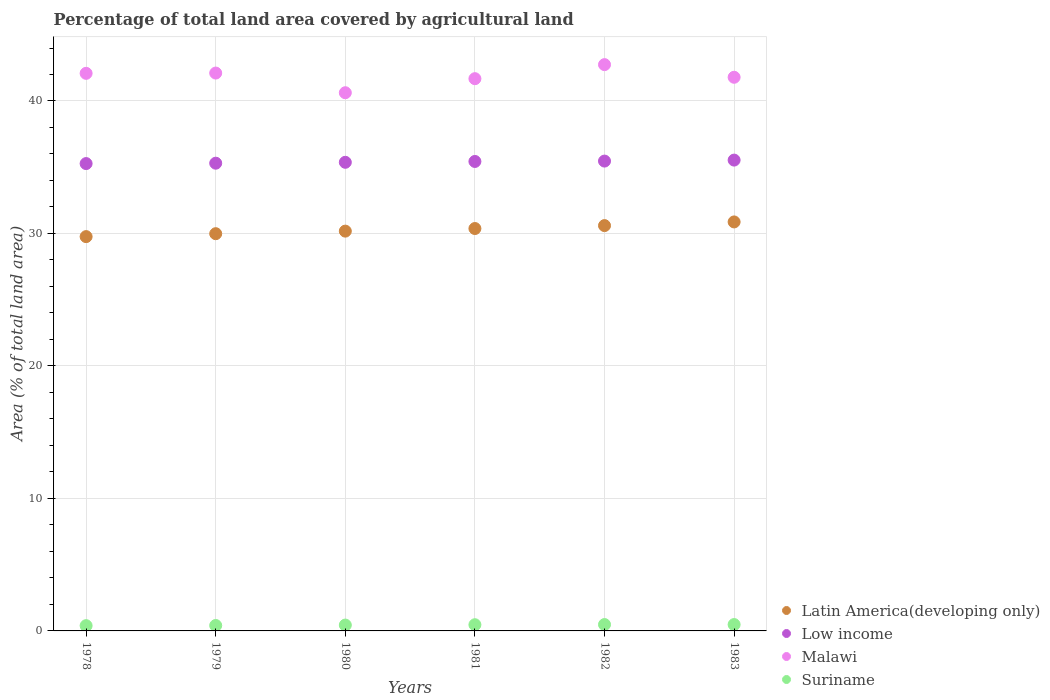Is the number of dotlines equal to the number of legend labels?
Make the answer very short. Yes. What is the percentage of agricultural land in Low income in 1982?
Offer a terse response. 35.46. Across all years, what is the maximum percentage of agricultural land in Low income?
Your response must be concise. 35.54. Across all years, what is the minimum percentage of agricultural land in Malawi?
Keep it short and to the point. 40.62. In which year was the percentage of agricultural land in Malawi maximum?
Keep it short and to the point. 1982. In which year was the percentage of agricultural land in Malawi minimum?
Your response must be concise. 1980. What is the total percentage of agricultural land in Latin America(developing only) in the graph?
Your response must be concise. 181.76. What is the difference between the percentage of agricultural land in Latin America(developing only) in 1980 and that in 1982?
Keep it short and to the point. -0.42. What is the difference between the percentage of agricultural land in Malawi in 1979 and the percentage of agricultural land in Latin America(developing only) in 1983?
Your answer should be compact. 11.24. What is the average percentage of agricultural land in Latin America(developing only) per year?
Provide a succinct answer. 30.29. In the year 1979, what is the difference between the percentage of agricultural land in Latin America(developing only) and percentage of agricultural land in Suriname?
Your answer should be very brief. 29.57. In how many years, is the percentage of agricultural land in Latin America(developing only) greater than 36 %?
Provide a succinct answer. 0. What is the ratio of the percentage of agricultural land in Malawi in 1978 to that in 1982?
Give a very brief answer. 0.98. What is the difference between the highest and the second highest percentage of agricultural land in Latin America(developing only)?
Ensure brevity in your answer.  0.28. What is the difference between the highest and the lowest percentage of agricultural land in Suriname?
Your answer should be very brief. 0.08. In how many years, is the percentage of agricultural land in Latin America(developing only) greater than the average percentage of agricultural land in Latin America(developing only) taken over all years?
Keep it short and to the point. 3. Does the percentage of agricultural land in Malawi monotonically increase over the years?
Provide a succinct answer. No. Is the percentage of agricultural land in Low income strictly less than the percentage of agricultural land in Malawi over the years?
Your response must be concise. Yes. What is the difference between two consecutive major ticks on the Y-axis?
Give a very brief answer. 10. Are the values on the major ticks of Y-axis written in scientific E-notation?
Make the answer very short. No. Does the graph contain any zero values?
Keep it short and to the point. No. Where does the legend appear in the graph?
Ensure brevity in your answer.  Bottom right. How many legend labels are there?
Make the answer very short. 4. How are the legend labels stacked?
Your answer should be compact. Vertical. What is the title of the graph?
Your answer should be compact. Percentage of total land area covered by agricultural land. Does "Peru" appear as one of the legend labels in the graph?
Make the answer very short. No. What is the label or title of the X-axis?
Provide a succinct answer. Years. What is the label or title of the Y-axis?
Provide a succinct answer. Area (% of total land area). What is the Area (% of total land area) of Latin America(developing only) in 1978?
Offer a very short reply. 29.76. What is the Area (% of total land area) in Low income in 1978?
Provide a short and direct response. 35.28. What is the Area (% of total land area) in Malawi in 1978?
Make the answer very short. 42.09. What is the Area (% of total land area) in Suriname in 1978?
Your answer should be very brief. 0.4. What is the Area (% of total land area) in Latin America(developing only) in 1979?
Your answer should be compact. 29.98. What is the Area (% of total land area) of Low income in 1979?
Your response must be concise. 35.31. What is the Area (% of total land area) of Malawi in 1979?
Ensure brevity in your answer.  42.11. What is the Area (% of total land area) in Suriname in 1979?
Your answer should be compact. 0.41. What is the Area (% of total land area) in Latin America(developing only) in 1980?
Make the answer very short. 30.18. What is the Area (% of total land area) in Low income in 1980?
Your answer should be very brief. 35.37. What is the Area (% of total land area) in Malawi in 1980?
Make the answer very short. 40.62. What is the Area (% of total land area) in Suriname in 1980?
Offer a very short reply. 0.44. What is the Area (% of total land area) in Latin America(developing only) in 1981?
Your response must be concise. 30.37. What is the Area (% of total land area) in Low income in 1981?
Keep it short and to the point. 35.44. What is the Area (% of total land area) in Malawi in 1981?
Provide a succinct answer. 41.68. What is the Area (% of total land area) of Suriname in 1981?
Your response must be concise. 0.47. What is the Area (% of total land area) of Latin America(developing only) in 1982?
Give a very brief answer. 30.59. What is the Area (% of total land area) in Low income in 1982?
Give a very brief answer. 35.46. What is the Area (% of total land area) of Malawi in 1982?
Your response must be concise. 42.75. What is the Area (% of total land area) in Suriname in 1982?
Make the answer very short. 0.48. What is the Area (% of total land area) of Latin America(developing only) in 1983?
Your answer should be compact. 30.87. What is the Area (% of total land area) of Low income in 1983?
Ensure brevity in your answer.  35.54. What is the Area (% of total land area) in Malawi in 1983?
Offer a very short reply. 41.79. What is the Area (% of total land area) of Suriname in 1983?
Offer a terse response. 0.48. Across all years, what is the maximum Area (% of total land area) in Latin America(developing only)?
Make the answer very short. 30.87. Across all years, what is the maximum Area (% of total land area) in Low income?
Provide a succinct answer. 35.54. Across all years, what is the maximum Area (% of total land area) in Malawi?
Your answer should be compact. 42.75. Across all years, what is the maximum Area (% of total land area) in Suriname?
Offer a terse response. 0.48. Across all years, what is the minimum Area (% of total land area) of Latin America(developing only)?
Your response must be concise. 29.76. Across all years, what is the minimum Area (% of total land area) of Low income?
Your response must be concise. 35.28. Across all years, what is the minimum Area (% of total land area) in Malawi?
Your answer should be very brief. 40.62. Across all years, what is the minimum Area (% of total land area) in Suriname?
Give a very brief answer. 0.4. What is the total Area (% of total land area) in Latin America(developing only) in the graph?
Your response must be concise. 181.76. What is the total Area (% of total land area) of Low income in the graph?
Your answer should be compact. 212.39. What is the total Area (% of total land area) in Malawi in the graph?
Provide a short and direct response. 251.04. What is the total Area (% of total land area) of Suriname in the graph?
Ensure brevity in your answer.  2.68. What is the difference between the Area (% of total land area) in Latin America(developing only) in 1978 and that in 1979?
Your answer should be very brief. -0.22. What is the difference between the Area (% of total land area) in Low income in 1978 and that in 1979?
Keep it short and to the point. -0.03. What is the difference between the Area (% of total land area) of Malawi in 1978 and that in 1979?
Offer a terse response. -0.02. What is the difference between the Area (% of total land area) of Suriname in 1978 and that in 1979?
Your response must be concise. -0.01. What is the difference between the Area (% of total land area) of Latin America(developing only) in 1978 and that in 1980?
Provide a succinct answer. -0.41. What is the difference between the Area (% of total land area) of Low income in 1978 and that in 1980?
Give a very brief answer. -0.1. What is the difference between the Area (% of total land area) of Malawi in 1978 and that in 1980?
Offer a terse response. 1.46. What is the difference between the Area (% of total land area) in Suriname in 1978 and that in 1980?
Your response must be concise. -0.04. What is the difference between the Area (% of total land area) of Latin America(developing only) in 1978 and that in 1981?
Your answer should be very brief. -0.61. What is the difference between the Area (% of total land area) in Low income in 1978 and that in 1981?
Provide a succinct answer. -0.16. What is the difference between the Area (% of total land area) of Malawi in 1978 and that in 1981?
Make the answer very short. 0.4. What is the difference between the Area (% of total land area) of Suriname in 1978 and that in 1981?
Keep it short and to the point. -0.07. What is the difference between the Area (% of total land area) in Latin America(developing only) in 1978 and that in 1982?
Keep it short and to the point. -0.83. What is the difference between the Area (% of total land area) in Low income in 1978 and that in 1982?
Provide a short and direct response. -0.19. What is the difference between the Area (% of total land area) in Malawi in 1978 and that in 1982?
Give a very brief answer. -0.66. What is the difference between the Area (% of total land area) in Suriname in 1978 and that in 1982?
Ensure brevity in your answer.  -0.08. What is the difference between the Area (% of total land area) in Latin America(developing only) in 1978 and that in 1983?
Ensure brevity in your answer.  -1.11. What is the difference between the Area (% of total land area) of Low income in 1978 and that in 1983?
Offer a terse response. -0.26. What is the difference between the Area (% of total land area) of Malawi in 1978 and that in 1983?
Give a very brief answer. 0.3. What is the difference between the Area (% of total land area) of Suriname in 1978 and that in 1983?
Offer a very short reply. -0.08. What is the difference between the Area (% of total land area) of Latin America(developing only) in 1979 and that in 1980?
Keep it short and to the point. -0.19. What is the difference between the Area (% of total land area) of Low income in 1979 and that in 1980?
Offer a very short reply. -0.07. What is the difference between the Area (% of total land area) of Malawi in 1979 and that in 1980?
Your answer should be compact. 1.48. What is the difference between the Area (% of total land area) in Suriname in 1979 and that in 1980?
Give a very brief answer. -0.03. What is the difference between the Area (% of total land area) in Latin America(developing only) in 1979 and that in 1981?
Your response must be concise. -0.39. What is the difference between the Area (% of total land area) of Low income in 1979 and that in 1981?
Offer a terse response. -0.13. What is the difference between the Area (% of total land area) in Malawi in 1979 and that in 1981?
Offer a very short reply. 0.42. What is the difference between the Area (% of total land area) of Suriname in 1979 and that in 1981?
Offer a terse response. -0.06. What is the difference between the Area (% of total land area) of Latin America(developing only) in 1979 and that in 1982?
Your answer should be compact. -0.61. What is the difference between the Area (% of total land area) in Low income in 1979 and that in 1982?
Ensure brevity in your answer.  -0.16. What is the difference between the Area (% of total land area) in Malawi in 1979 and that in 1982?
Ensure brevity in your answer.  -0.64. What is the difference between the Area (% of total land area) in Suriname in 1979 and that in 1982?
Provide a short and direct response. -0.07. What is the difference between the Area (% of total land area) of Latin America(developing only) in 1979 and that in 1983?
Offer a terse response. -0.89. What is the difference between the Area (% of total land area) of Low income in 1979 and that in 1983?
Make the answer very short. -0.23. What is the difference between the Area (% of total land area) in Malawi in 1979 and that in 1983?
Ensure brevity in your answer.  0.32. What is the difference between the Area (% of total land area) in Suriname in 1979 and that in 1983?
Provide a succinct answer. -0.07. What is the difference between the Area (% of total land area) in Latin America(developing only) in 1980 and that in 1981?
Keep it short and to the point. -0.2. What is the difference between the Area (% of total land area) of Low income in 1980 and that in 1981?
Offer a very short reply. -0.06. What is the difference between the Area (% of total land area) in Malawi in 1980 and that in 1981?
Ensure brevity in your answer.  -1.06. What is the difference between the Area (% of total land area) of Suriname in 1980 and that in 1981?
Your response must be concise. -0.03. What is the difference between the Area (% of total land area) of Latin America(developing only) in 1980 and that in 1982?
Give a very brief answer. -0.42. What is the difference between the Area (% of total land area) of Low income in 1980 and that in 1982?
Your answer should be very brief. -0.09. What is the difference between the Area (% of total land area) in Malawi in 1980 and that in 1982?
Provide a short and direct response. -2.12. What is the difference between the Area (% of total land area) of Suriname in 1980 and that in 1982?
Give a very brief answer. -0.04. What is the difference between the Area (% of total land area) of Latin America(developing only) in 1980 and that in 1983?
Offer a very short reply. -0.69. What is the difference between the Area (% of total land area) of Low income in 1980 and that in 1983?
Offer a terse response. -0.17. What is the difference between the Area (% of total land area) in Malawi in 1980 and that in 1983?
Keep it short and to the point. -1.17. What is the difference between the Area (% of total land area) in Suriname in 1980 and that in 1983?
Your answer should be compact. -0.04. What is the difference between the Area (% of total land area) of Latin America(developing only) in 1981 and that in 1982?
Your response must be concise. -0.22. What is the difference between the Area (% of total land area) of Low income in 1981 and that in 1982?
Your answer should be very brief. -0.03. What is the difference between the Area (% of total land area) in Malawi in 1981 and that in 1982?
Ensure brevity in your answer.  -1.06. What is the difference between the Area (% of total land area) of Suriname in 1981 and that in 1982?
Your answer should be very brief. -0.01. What is the difference between the Area (% of total land area) of Latin America(developing only) in 1981 and that in 1983?
Ensure brevity in your answer.  -0.5. What is the difference between the Area (% of total land area) in Low income in 1981 and that in 1983?
Make the answer very short. -0.1. What is the difference between the Area (% of total land area) of Malawi in 1981 and that in 1983?
Your response must be concise. -0.11. What is the difference between the Area (% of total land area) in Suriname in 1981 and that in 1983?
Keep it short and to the point. -0.01. What is the difference between the Area (% of total land area) in Latin America(developing only) in 1982 and that in 1983?
Provide a short and direct response. -0.28. What is the difference between the Area (% of total land area) of Low income in 1982 and that in 1983?
Ensure brevity in your answer.  -0.07. What is the difference between the Area (% of total land area) of Malawi in 1982 and that in 1983?
Provide a short and direct response. 0.95. What is the difference between the Area (% of total land area) of Latin America(developing only) in 1978 and the Area (% of total land area) of Low income in 1979?
Your response must be concise. -5.54. What is the difference between the Area (% of total land area) in Latin America(developing only) in 1978 and the Area (% of total land area) in Malawi in 1979?
Give a very brief answer. -12.35. What is the difference between the Area (% of total land area) of Latin America(developing only) in 1978 and the Area (% of total land area) of Suriname in 1979?
Give a very brief answer. 29.35. What is the difference between the Area (% of total land area) in Low income in 1978 and the Area (% of total land area) in Malawi in 1979?
Offer a terse response. -6.83. What is the difference between the Area (% of total land area) in Low income in 1978 and the Area (% of total land area) in Suriname in 1979?
Give a very brief answer. 34.87. What is the difference between the Area (% of total land area) in Malawi in 1978 and the Area (% of total land area) in Suriname in 1979?
Make the answer very short. 41.68. What is the difference between the Area (% of total land area) in Latin America(developing only) in 1978 and the Area (% of total land area) in Low income in 1980?
Your answer should be compact. -5.61. What is the difference between the Area (% of total land area) in Latin America(developing only) in 1978 and the Area (% of total land area) in Malawi in 1980?
Keep it short and to the point. -10.86. What is the difference between the Area (% of total land area) of Latin America(developing only) in 1978 and the Area (% of total land area) of Suriname in 1980?
Offer a terse response. 29.32. What is the difference between the Area (% of total land area) in Low income in 1978 and the Area (% of total land area) in Malawi in 1980?
Provide a short and direct response. -5.35. What is the difference between the Area (% of total land area) of Low income in 1978 and the Area (% of total land area) of Suriname in 1980?
Your response must be concise. 34.83. What is the difference between the Area (% of total land area) of Malawi in 1978 and the Area (% of total land area) of Suriname in 1980?
Provide a succinct answer. 41.65. What is the difference between the Area (% of total land area) in Latin America(developing only) in 1978 and the Area (% of total land area) in Low income in 1981?
Your answer should be compact. -5.67. What is the difference between the Area (% of total land area) of Latin America(developing only) in 1978 and the Area (% of total land area) of Malawi in 1981?
Offer a terse response. -11.92. What is the difference between the Area (% of total land area) in Latin America(developing only) in 1978 and the Area (% of total land area) in Suriname in 1981?
Provide a succinct answer. 29.29. What is the difference between the Area (% of total land area) of Low income in 1978 and the Area (% of total land area) of Malawi in 1981?
Make the answer very short. -6.41. What is the difference between the Area (% of total land area) in Low income in 1978 and the Area (% of total land area) in Suriname in 1981?
Your answer should be very brief. 34.81. What is the difference between the Area (% of total land area) in Malawi in 1978 and the Area (% of total land area) in Suriname in 1981?
Ensure brevity in your answer.  41.62. What is the difference between the Area (% of total land area) of Latin America(developing only) in 1978 and the Area (% of total land area) of Low income in 1982?
Provide a short and direct response. -5.7. What is the difference between the Area (% of total land area) in Latin America(developing only) in 1978 and the Area (% of total land area) in Malawi in 1982?
Your response must be concise. -12.98. What is the difference between the Area (% of total land area) of Latin America(developing only) in 1978 and the Area (% of total land area) of Suriname in 1982?
Provide a short and direct response. 29.28. What is the difference between the Area (% of total land area) of Low income in 1978 and the Area (% of total land area) of Malawi in 1982?
Make the answer very short. -7.47. What is the difference between the Area (% of total land area) in Low income in 1978 and the Area (% of total land area) in Suriname in 1982?
Ensure brevity in your answer.  34.8. What is the difference between the Area (% of total land area) of Malawi in 1978 and the Area (% of total land area) of Suriname in 1982?
Ensure brevity in your answer.  41.61. What is the difference between the Area (% of total land area) of Latin America(developing only) in 1978 and the Area (% of total land area) of Low income in 1983?
Make the answer very short. -5.78. What is the difference between the Area (% of total land area) of Latin America(developing only) in 1978 and the Area (% of total land area) of Malawi in 1983?
Provide a succinct answer. -12.03. What is the difference between the Area (% of total land area) of Latin America(developing only) in 1978 and the Area (% of total land area) of Suriname in 1983?
Your answer should be very brief. 29.28. What is the difference between the Area (% of total land area) of Low income in 1978 and the Area (% of total land area) of Malawi in 1983?
Your answer should be compact. -6.51. What is the difference between the Area (% of total land area) in Low income in 1978 and the Area (% of total land area) in Suriname in 1983?
Give a very brief answer. 34.8. What is the difference between the Area (% of total land area) of Malawi in 1978 and the Area (% of total land area) of Suriname in 1983?
Offer a terse response. 41.61. What is the difference between the Area (% of total land area) of Latin America(developing only) in 1979 and the Area (% of total land area) of Low income in 1980?
Provide a short and direct response. -5.39. What is the difference between the Area (% of total land area) of Latin America(developing only) in 1979 and the Area (% of total land area) of Malawi in 1980?
Ensure brevity in your answer.  -10.64. What is the difference between the Area (% of total land area) of Latin America(developing only) in 1979 and the Area (% of total land area) of Suriname in 1980?
Offer a terse response. 29.54. What is the difference between the Area (% of total land area) of Low income in 1979 and the Area (% of total land area) of Malawi in 1980?
Offer a very short reply. -5.32. What is the difference between the Area (% of total land area) in Low income in 1979 and the Area (% of total land area) in Suriname in 1980?
Provide a succinct answer. 34.86. What is the difference between the Area (% of total land area) of Malawi in 1979 and the Area (% of total land area) of Suriname in 1980?
Keep it short and to the point. 41.67. What is the difference between the Area (% of total land area) in Latin America(developing only) in 1979 and the Area (% of total land area) in Low income in 1981?
Ensure brevity in your answer.  -5.45. What is the difference between the Area (% of total land area) of Latin America(developing only) in 1979 and the Area (% of total land area) of Malawi in 1981?
Your response must be concise. -11.7. What is the difference between the Area (% of total land area) of Latin America(developing only) in 1979 and the Area (% of total land area) of Suriname in 1981?
Your answer should be very brief. 29.52. What is the difference between the Area (% of total land area) of Low income in 1979 and the Area (% of total land area) of Malawi in 1981?
Offer a terse response. -6.38. What is the difference between the Area (% of total land area) of Low income in 1979 and the Area (% of total land area) of Suriname in 1981?
Provide a succinct answer. 34.84. What is the difference between the Area (% of total land area) in Malawi in 1979 and the Area (% of total land area) in Suriname in 1981?
Provide a succinct answer. 41.64. What is the difference between the Area (% of total land area) of Latin America(developing only) in 1979 and the Area (% of total land area) of Low income in 1982?
Make the answer very short. -5.48. What is the difference between the Area (% of total land area) of Latin America(developing only) in 1979 and the Area (% of total land area) of Malawi in 1982?
Ensure brevity in your answer.  -12.76. What is the difference between the Area (% of total land area) in Latin America(developing only) in 1979 and the Area (% of total land area) in Suriname in 1982?
Provide a short and direct response. 29.5. What is the difference between the Area (% of total land area) of Low income in 1979 and the Area (% of total land area) of Malawi in 1982?
Offer a terse response. -7.44. What is the difference between the Area (% of total land area) of Low income in 1979 and the Area (% of total land area) of Suriname in 1982?
Offer a very short reply. 34.82. What is the difference between the Area (% of total land area) in Malawi in 1979 and the Area (% of total land area) in Suriname in 1982?
Keep it short and to the point. 41.63. What is the difference between the Area (% of total land area) in Latin America(developing only) in 1979 and the Area (% of total land area) in Low income in 1983?
Provide a short and direct response. -5.55. What is the difference between the Area (% of total land area) of Latin America(developing only) in 1979 and the Area (% of total land area) of Malawi in 1983?
Provide a succinct answer. -11.81. What is the difference between the Area (% of total land area) of Latin America(developing only) in 1979 and the Area (% of total land area) of Suriname in 1983?
Ensure brevity in your answer.  29.5. What is the difference between the Area (% of total land area) in Low income in 1979 and the Area (% of total land area) in Malawi in 1983?
Offer a very short reply. -6.49. What is the difference between the Area (% of total land area) in Low income in 1979 and the Area (% of total land area) in Suriname in 1983?
Give a very brief answer. 34.82. What is the difference between the Area (% of total land area) in Malawi in 1979 and the Area (% of total land area) in Suriname in 1983?
Give a very brief answer. 41.63. What is the difference between the Area (% of total land area) in Latin America(developing only) in 1980 and the Area (% of total land area) in Low income in 1981?
Your answer should be very brief. -5.26. What is the difference between the Area (% of total land area) of Latin America(developing only) in 1980 and the Area (% of total land area) of Malawi in 1981?
Your answer should be very brief. -11.51. What is the difference between the Area (% of total land area) of Latin America(developing only) in 1980 and the Area (% of total land area) of Suriname in 1981?
Provide a short and direct response. 29.71. What is the difference between the Area (% of total land area) of Low income in 1980 and the Area (% of total land area) of Malawi in 1981?
Give a very brief answer. -6.31. What is the difference between the Area (% of total land area) of Low income in 1980 and the Area (% of total land area) of Suriname in 1981?
Your response must be concise. 34.9. What is the difference between the Area (% of total land area) in Malawi in 1980 and the Area (% of total land area) in Suriname in 1981?
Ensure brevity in your answer.  40.16. What is the difference between the Area (% of total land area) of Latin America(developing only) in 1980 and the Area (% of total land area) of Low income in 1982?
Provide a short and direct response. -5.29. What is the difference between the Area (% of total land area) in Latin America(developing only) in 1980 and the Area (% of total land area) in Malawi in 1982?
Your answer should be very brief. -12.57. What is the difference between the Area (% of total land area) of Latin America(developing only) in 1980 and the Area (% of total land area) of Suriname in 1982?
Provide a short and direct response. 29.7. What is the difference between the Area (% of total land area) of Low income in 1980 and the Area (% of total land area) of Malawi in 1982?
Provide a short and direct response. -7.37. What is the difference between the Area (% of total land area) in Low income in 1980 and the Area (% of total land area) in Suriname in 1982?
Your response must be concise. 34.89. What is the difference between the Area (% of total land area) of Malawi in 1980 and the Area (% of total land area) of Suriname in 1982?
Provide a short and direct response. 40.14. What is the difference between the Area (% of total land area) of Latin America(developing only) in 1980 and the Area (% of total land area) of Low income in 1983?
Provide a succinct answer. -5.36. What is the difference between the Area (% of total land area) in Latin America(developing only) in 1980 and the Area (% of total land area) in Malawi in 1983?
Your response must be concise. -11.61. What is the difference between the Area (% of total land area) in Latin America(developing only) in 1980 and the Area (% of total land area) in Suriname in 1983?
Provide a short and direct response. 29.7. What is the difference between the Area (% of total land area) in Low income in 1980 and the Area (% of total land area) in Malawi in 1983?
Offer a very short reply. -6.42. What is the difference between the Area (% of total land area) of Low income in 1980 and the Area (% of total land area) of Suriname in 1983?
Your answer should be very brief. 34.89. What is the difference between the Area (% of total land area) of Malawi in 1980 and the Area (% of total land area) of Suriname in 1983?
Ensure brevity in your answer.  40.14. What is the difference between the Area (% of total land area) in Latin America(developing only) in 1981 and the Area (% of total land area) in Low income in 1982?
Provide a short and direct response. -5.09. What is the difference between the Area (% of total land area) in Latin America(developing only) in 1981 and the Area (% of total land area) in Malawi in 1982?
Offer a terse response. -12.37. What is the difference between the Area (% of total land area) of Latin America(developing only) in 1981 and the Area (% of total land area) of Suriname in 1982?
Provide a succinct answer. 29.89. What is the difference between the Area (% of total land area) in Low income in 1981 and the Area (% of total land area) in Malawi in 1982?
Make the answer very short. -7.31. What is the difference between the Area (% of total land area) of Low income in 1981 and the Area (% of total land area) of Suriname in 1982?
Your response must be concise. 34.96. What is the difference between the Area (% of total land area) of Malawi in 1981 and the Area (% of total land area) of Suriname in 1982?
Provide a short and direct response. 41.2. What is the difference between the Area (% of total land area) of Latin America(developing only) in 1981 and the Area (% of total land area) of Low income in 1983?
Your answer should be very brief. -5.17. What is the difference between the Area (% of total land area) of Latin America(developing only) in 1981 and the Area (% of total land area) of Malawi in 1983?
Keep it short and to the point. -11.42. What is the difference between the Area (% of total land area) in Latin America(developing only) in 1981 and the Area (% of total land area) in Suriname in 1983?
Ensure brevity in your answer.  29.89. What is the difference between the Area (% of total land area) in Low income in 1981 and the Area (% of total land area) in Malawi in 1983?
Make the answer very short. -6.35. What is the difference between the Area (% of total land area) in Low income in 1981 and the Area (% of total land area) in Suriname in 1983?
Give a very brief answer. 34.96. What is the difference between the Area (% of total land area) of Malawi in 1981 and the Area (% of total land area) of Suriname in 1983?
Your answer should be compact. 41.2. What is the difference between the Area (% of total land area) in Latin America(developing only) in 1982 and the Area (% of total land area) in Low income in 1983?
Your answer should be very brief. -4.94. What is the difference between the Area (% of total land area) in Latin America(developing only) in 1982 and the Area (% of total land area) in Malawi in 1983?
Keep it short and to the point. -11.2. What is the difference between the Area (% of total land area) of Latin America(developing only) in 1982 and the Area (% of total land area) of Suriname in 1983?
Make the answer very short. 30.11. What is the difference between the Area (% of total land area) in Low income in 1982 and the Area (% of total land area) in Malawi in 1983?
Make the answer very short. -6.33. What is the difference between the Area (% of total land area) in Low income in 1982 and the Area (% of total land area) in Suriname in 1983?
Make the answer very short. 34.98. What is the difference between the Area (% of total land area) in Malawi in 1982 and the Area (% of total land area) in Suriname in 1983?
Offer a very short reply. 42.26. What is the average Area (% of total land area) in Latin America(developing only) per year?
Make the answer very short. 30.29. What is the average Area (% of total land area) of Low income per year?
Ensure brevity in your answer.  35.4. What is the average Area (% of total land area) of Malawi per year?
Your answer should be compact. 41.84. What is the average Area (% of total land area) of Suriname per year?
Ensure brevity in your answer.  0.45. In the year 1978, what is the difference between the Area (% of total land area) of Latin America(developing only) and Area (% of total land area) of Low income?
Give a very brief answer. -5.51. In the year 1978, what is the difference between the Area (% of total land area) in Latin America(developing only) and Area (% of total land area) in Malawi?
Ensure brevity in your answer.  -12.32. In the year 1978, what is the difference between the Area (% of total land area) of Latin America(developing only) and Area (% of total land area) of Suriname?
Keep it short and to the point. 29.37. In the year 1978, what is the difference between the Area (% of total land area) of Low income and Area (% of total land area) of Malawi?
Offer a very short reply. -6.81. In the year 1978, what is the difference between the Area (% of total land area) in Low income and Area (% of total land area) in Suriname?
Your response must be concise. 34.88. In the year 1978, what is the difference between the Area (% of total land area) in Malawi and Area (% of total land area) in Suriname?
Offer a very short reply. 41.69. In the year 1979, what is the difference between the Area (% of total land area) in Latin America(developing only) and Area (% of total land area) in Low income?
Your answer should be compact. -5.32. In the year 1979, what is the difference between the Area (% of total land area) in Latin America(developing only) and Area (% of total land area) in Malawi?
Provide a succinct answer. -12.12. In the year 1979, what is the difference between the Area (% of total land area) in Latin America(developing only) and Area (% of total land area) in Suriname?
Give a very brief answer. 29.57. In the year 1979, what is the difference between the Area (% of total land area) in Low income and Area (% of total land area) in Malawi?
Your answer should be very brief. -6.8. In the year 1979, what is the difference between the Area (% of total land area) of Low income and Area (% of total land area) of Suriname?
Ensure brevity in your answer.  34.89. In the year 1979, what is the difference between the Area (% of total land area) of Malawi and Area (% of total land area) of Suriname?
Give a very brief answer. 41.7. In the year 1980, what is the difference between the Area (% of total land area) of Latin America(developing only) and Area (% of total land area) of Low income?
Offer a very short reply. -5.2. In the year 1980, what is the difference between the Area (% of total land area) in Latin America(developing only) and Area (% of total land area) in Malawi?
Give a very brief answer. -10.45. In the year 1980, what is the difference between the Area (% of total land area) in Latin America(developing only) and Area (% of total land area) in Suriname?
Give a very brief answer. 29.73. In the year 1980, what is the difference between the Area (% of total land area) in Low income and Area (% of total land area) in Malawi?
Keep it short and to the point. -5.25. In the year 1980, what is the difference between the Area (% of total land area) in Low income and Area (% of total land area) in Suriname?
Provide a succinct answer. 34.93. In the year 1980, what is the difference between the Area (% of total land area) in Malawi and Area (% of total land area) in Suriname?
Your answer should be compact. 40.18. In the year 1981, what is the difference between the Area (% of total land area) in Latin America(developing only) and Area (% of total land area) in Low income?
Your answer should be compact. -5.06. In the year 1981, what is the difference between the Area (% of total land area) of Latin America(developing only) and Area (% of total land area) of Malawi?
Your answer should be compact. -11.31. In the year 1981, what is the difference between the Area (% of total land area) of Latin America(developing only) and Area (% of total land area) of Suriname?
Offer a very short reply. 29.91. In the year 1981, what is the difference between the Area (% of total land area) of Low income and Area (% of total land area) of Malawi?
Give a very brief answer. -6.25. In the year 1981, what is the difference between the Area (% of total land area) in Low income and Area (% of total land area) in Suriname?
Make the answer very short. 34.97. In the year 1981, what is the difference between the Area (% of total land area) of Malawi and Area (% of total land area) of Suriname?
Ensure brevity in your answer.  41.22. In the year 1982, what is the difference between the Area (% of total land area) in Latin America(developing only) and Area (% of total land area) in Low income?
Keep it short and to the point. -4.87. In the year 1982, what is the difference between the Area (% of total land area) of Latin America(developing only) and Area (% of total land area) of Malawi?
Provide a succinct answer. -12.15. In the year 1982, what is the difference between the Area (% of total land area) of Latin America(developing only) and Area (% of total land area) of Suriname?
Your answer should be compact. 30.11. In the year 1982, what is the difference between the Area (% of total land area) of Low income and Area (% of total land area) of Malawi?
Provide a short and direct response. -7.28. In the year 1982, what is the difference between the Area (% of total land area) in Low income and Area (% of total land area) in Suriname?
Provide a succinct answer. 34.98. In the year 1982, what is the difference between the Area (% of total land area) of Malawi and Area (% of total land area) of Suriname?
Your response must be concise. 42.26. In the year 1983, what is the difference between the Area (% of total land area) in Latin America(developing only) and Area (% of total land area) in Low income?
Provide a short and direct response. -4.67. In the year 1983, what is the difference between the Area (% of total land area) in Latin America(developing only) and Area (% of total land area) in Malawi?
Your answer should be very brief. -10.92. In the year 1983, what is the difference between the Area (% of total land area) of Latin America(developing only) and Area (% of total land area) of Suriname?
Keep it short and to the point. 30.39. In the year 1983, what is the difference between the Area (% of total land area) of Low income and Area (% of total land area) of Malawi?
Provide a succinct answer. -6.25. In the year 1983, what is the difference between the Area (% of total land area) in Low income and Area (% of total land area) in Suriname?
Offer a very short reply. 35.06. In the year 1983, what is the difference between the Area (% of total land area) in Malawi and Area (% of total land area) in Suriname?
Ensure brevity in your answer.  41.31. What is the ratio of the Area (% of total land area) in Low income in 1978 to that in 1979?
Offer a very short reply. 1. What is the ratio of the Area (% of total land area) of Malawi in 1978 to that in 1979?
Keep it short and to the point. 1. What is the ratio of the Area (% of total land area) of Suriname in 1978 to that in 1979?
Ensure brevity in your answer.  0.97. What is the ratio of the Area (% of total land area) in Latin America(developing only) in 1978 to that in 1980?
Give a very brief answer. 0.99. What is the ratio of the Area (% of total land area) in Low income in 1978 to that in 1980?
Make the answer very short. 1. What is the ratio of the Area (% of total land area) in Malawi in 1978 to that in 1980?
Make the answer very short. 1.04. What is the ratio of the Area (% of total land area) of Suriname in 1978 to that in 1980?
Keep it short and to the point. 0.9. What is the ratio of the Area (% of total land area) in Latin America(developing only) in 1978 to that in 1981?
Give a very brief answer. 0.98. What is the ratio of the Area (% of total land area) in Malawi in 1978 to that in 1981?
Offer a terse response. 1.01. What is the ratio of the Area (% of total land area) of Suriname in 1978 to that in 1981?
Give a very brief answer. 0.85. What is the ratio of the Area (% of total land area) in Latin America(developing only) in 1978 to that in 1982?
Your answer should be very brief. 0.97. What is the ratio of the Area (% of total land area) in Low income in 1978 to that in 1982?
Provide a succinct answer. 0.99. What is the ratio of the Area (% of total land area) of Malawi in 1978 to that in 1982?
Your answer should be very brief. 0.98. What is the ratio of the Area (% of total land area) in Suriname in 1978 to that in 1982?
Provide a succinct answer. 0.83. What is the ratio of the Area (% of total land area) of Latin America(developing only) in 1978 to that in 1983?
Give a very brief answer. 0.96. What is the ratio of the Area (% of total land area) of Low income in 1978 to that in 1983?
Make the answer very short. 0.99. What is the ratio of the Area (% of total land area) in Malawi in 1978 to that in 1983?
Offer a terse response. 1.01. What is the ratio of the Area (% of total land area) in Suriname in 1978 to that in 1983?
Offer a terse response. 0.83. What is the ratio of the Area (% of total land area) in Latin America(developing only) in 1979 to that in 1980?
Offer a very short reply. 0.99. What is the ratio of the Area (% of total land area) of Low income in 1979 to that in 1980?
Keep it short and to the point. 1. What is the ratio of the Area (% of total land area) of Malawi in 1979 to that in 1980?
Your response must be concise. 1.04. What is the ratio of the Area (% of total land area) in Suriname in 1979 to that in 1980?
Your answer should be compact. 0.93. What is the ratio of the Area (% of total land area) of Latin America(developing only) in 1979 to that in 1981?
Give a very brief answer. 0.99. What is the ratio of the Area (% of total land area) in Low income in 1979 to that in 1981?
Offer a very short reply. 1. What is the ratio of the Area (% of total land area) of Malawi in 1979 to that in 1981?
Give a very brief answer. 1.01. What is the ratio of the Area (% of total land area) of Suriname in 1979 to that in 1981?
Offer a very short reply. 0.88. What is the ratio of the Area (% of total land area) of Latin America(developing only) in 1979 to that in 1982?
Your answer should be compact. 0.98. What is the ratio of the Area (% of total land area) in Low income in 1979 to that in 1982?
Your answer should be compact. 1. What is the ratio of the Area (% of total land area) in Malawi in 1979 to that in 1982?
Your answer should be compact. 0.99. What is the ratio of the Area (% of total land area) of Suriname in 1979 to that in 1982?
Make the answer very short. 0.85. What is the ratio of the Area (% of total land area) of Latin America(developing only) in 1979 to that in 1983?
Your answer should be compact. 0.97. What is the ratio of the Area (% of total land area) of Malawi in 1979 to that in 1983?
Offer a terse response. 1.01. What is the ratio of the Area (% of total land area) of Suriname in 1979 to that in 1983?
Provide a succinct answer. 0.85. What is the ratio of the Area (% of total land area) in Latin America(developing only) in 1980 to that in 1981?
Provide a short and direct response. 0.99. What is the ratio of the Area (% of total land area) in Low income in 1980 to that in 1981?
Ensure brevity in your answer.  1. What is the ratio of the Area (% of total land area) in Malawi in 1980 to that in 1981?
Offer a very short reply. 0.97. What is the ratio of the Area (% of total land area) in Suriname in 1980 to that in 1981?
Ensure brevity in your answer.  0.95. What is the ratio of the Area (% of total land area) in Latin America(developing only) in 1980 to that in 1982?
Your answer should be compact. 0.99. What is the ratio of the Area (% of total land area) of Malawi in 1980 to that in 1982?
Your answer should be very brief. 0.95. What is the ratio of the Area (% of total land area) in Suriname in 1980 to that in 1982?
Your answer should be compact. 0.92. What is the ratio of the Area (% of total land area) of Latin America(developing only) in 1980 to that in 1983?
Provide a succinct answer. 0.98. What is the ratio of the Area (% of total land area) of Low income in 1980 to that in 1983?
Offer a terse response. 1. What is the ratio of the Area (% of total land area) of Malawi in 1980 to that in 1983?
Offer a terse response. 0.97. What is the ratio of the Area (% of total land area) in Suriname in 1980 to that in 1983?
Offer a very short reply. 0.92. What is the ratio of the Area (% of total land area) in Low income in 1981 to that in 1982?
Your response must be concise. 1. What is the ratio of the Area (% of total land area) of Malawi in 1981 to that in 1982?
Ensure brevity in your answer.  0.98. What is the ratio of the Area (% of total land area) of Suriname in 1981 to that in 1982?
Provide a succinct answer. 0.97. What is the ratio of the Area (% of total land area) of Latin America(developing only) in 1981 to that in 1983?
Make the answer very short. 0.98. What is the ratio of the Area (% of total land area) of Low income in 1981 to that in 1983?
Offer a very short reply. 1. What is the ratio of the Area (% of total land area) of Suriname in 1981 to that in 1983?
Keep it short and to the point. 0.97. What is the ratio of the Area (% of total land area) of Latin America(developing only) in 1982 to that in 1983?
Your answer should be compact. 0.99. What is the ratio of the Area (% of total land area) in Malawi in 1982 to that in 1983?
Your response must be concise. 1.02. What is the difference between the highest and the second highest Area (% of total land area) of Latin America(developing only)?
Offer a very short reply. 0.28. What is the difference between the highest and the second highest Area (% of total land area) in Low income?
Make the answer very short. 0.07. What is the difference between the highest and the second highest Area (% of total land area) of Malawi?
Ensure brevity in your answer.  0.64. What is the difference between the highest and the second highest Area (% of total land area) in Suriname?
Provide a short and direct response. 0. What is the difference between the highest and the lowest Area (% of total land area) in Latin America(developing only)?
Your response must be concise. 1.11. What is the difference between the highest and the lowest Area (% of total land area) in Low income?
Offer a very short reply. 0.26. What is the difference between the highest and the lowest Area (% of total land area) in Malawi?
Give a very brief answer. 2.12. What is the difference between the highest and the lowest Area (% of total land area) of Suriname?
Provide a succinct answer. 0.08. 